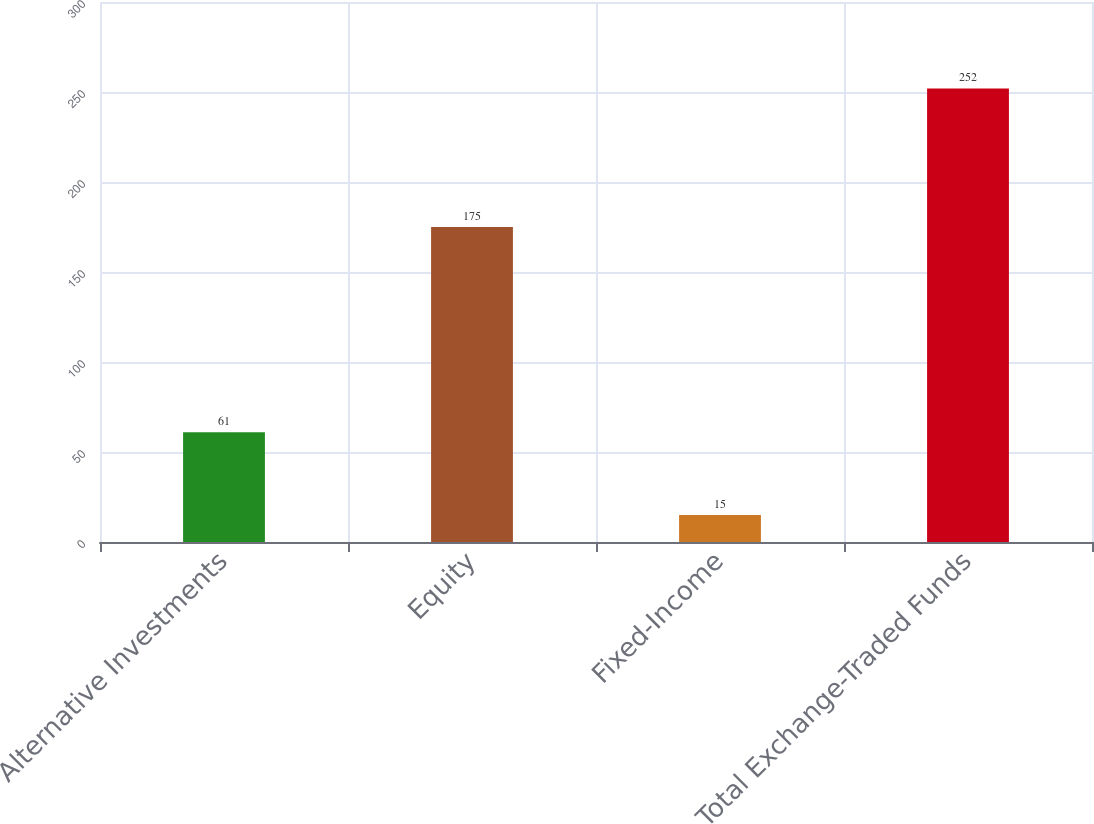<chart> <loc_0><loc_0><loc_500><loc_500><bar_chart><fcel>Alternative Investments<fcel>Equity<fcel>Fixed-Income<fcel>Total Exchange-Traded Funds<nl><fcel>61<fcel>175<fcel>15<fcel>252<nl></chart> 